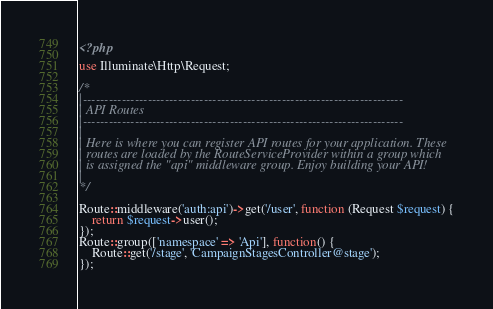Convert code to text. <code><loc_0><loc_0><loc_500><loc_500><_PHP_><?php

use Illuminate\Http\Request;

/*
|--------------------------------------------------------------------------
| API Routes
|--------------------------------------------------------------------------
|
| Here is where you can register API routes for your application. These
| routes are loaded by the RouteServiceProvider within a group which
| is assigned the "api" middleware group. Enjoy building your API!
|
*/

Route::middleware('auth:api')->get('/user', function (Request $request) {
    return $request->user();
});
Route::group(['namespace' => 'Api'], function() {
    Route::get('/stage', 'CampaignStagesController@stage');
});
</code> 